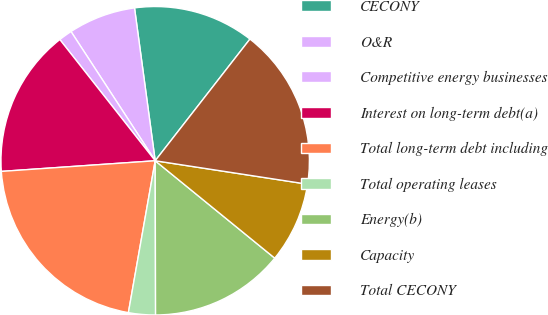Convert chart to OTSL. <chart><loc_0><loc_0><loc_500><loc_500><pie_chart><fcel>CECONY<fcel>O&R<fcel>Competitive energy businesses<fcel>Interest on long-term debt(a)<fcel>Total long-term debt including<fcel>Total operating leases<fcel>Energy(b)<fcel>Capacity<fcel>Total CECONY<nl><fcel>12.67%<fcel>7.05%<fcel>1.42%<fcel>15.49%<fcel>21.12%<fcel>2.82%<fcel>14.08%<fcel>8.45%<fcel>16.9%<nl></chart> 